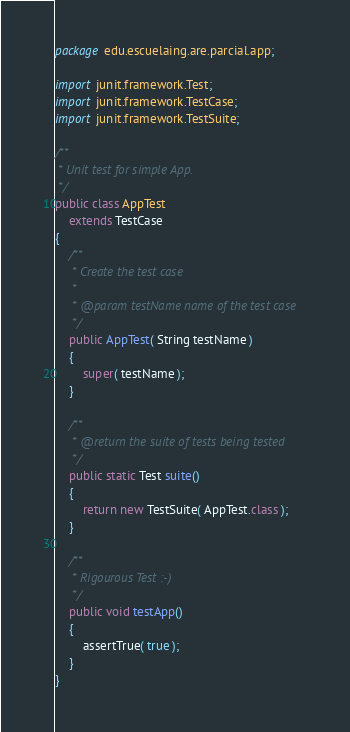Convert code to text. <code><loc_0><loc_0><loc_500><loc_500><_Java_>package edu.escuelaing.are.parcial.app;

import junit.framework.Test;
import junit.framework.TestCase;
import junit.framework.TestSuite;

/**
 * Unit test for simple App.
 */
public class AppTest 
    extends TestCase
{
    /**
     * Create the test case
     *
     * @param testName name of the test case
     */
    public AppTest( String testName )
    {
        super( testName );
    }

    /**
     * @return the suite of tests being tested
     */
    public static Test suite()
    {
        return new TestSuite( AppTest.class );
    }

    /**
     * Rigourous Test :-)
     */
    public void testApp()
    {
        assertTrue( true );
    }
}</code> 